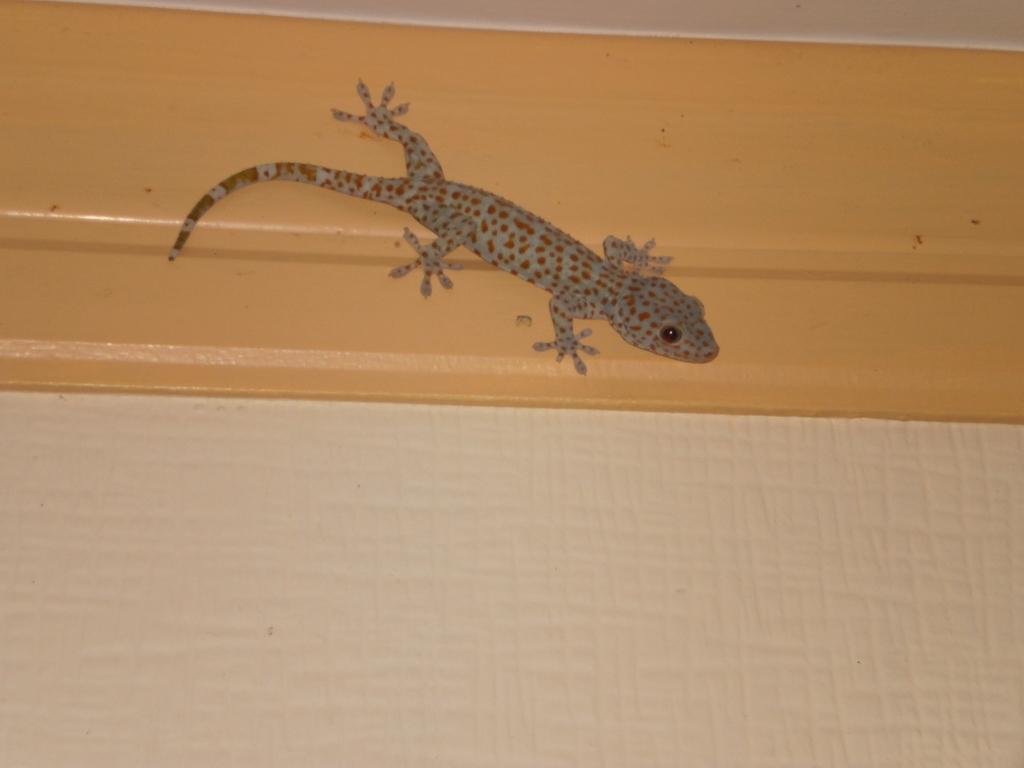What type of animal is in the image? There is a lizard in the image. Where is the lizard located? The lizard is on the wall. What type of club is the lizard holding in the image? There is no club present in the image; the lizard is simply on the wall. 